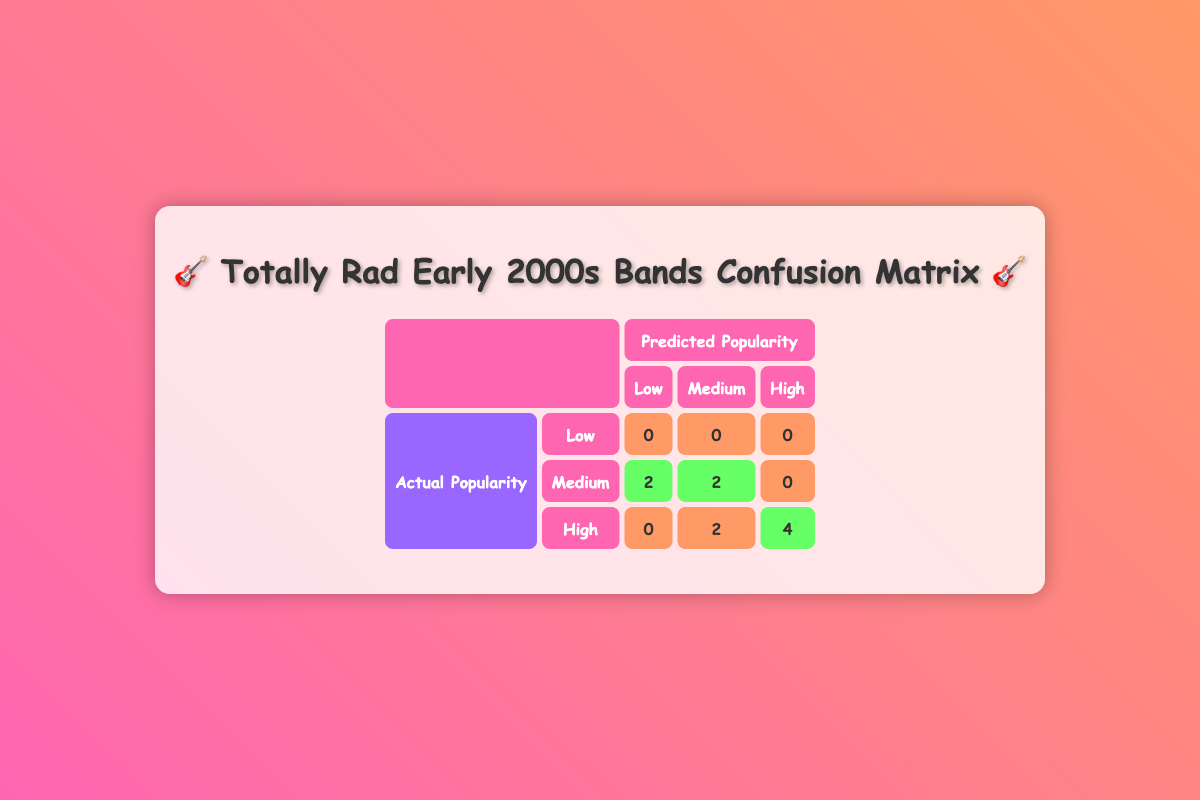What is the total number of artists classified as "Medium" in predicted popularity? In the table, we look at the row for "Medium" under "Predicted Popularity". There are two occurrences of "2" in that row, which indicate that there are two artists with "Medium" predicted popularity classified as "Medium" in actual popularity. Therefore, the total is 2 + 2 = 4.
Answer: 4 How many artists were correctly predicted as "High" based on social media engagement? We look at the row for "High" under "Actual Popularity". The last column for "High" shows "4", indicating that 4 artists were correctly predicted as high popularity.
Answer: 4 Is it true that no artists were predicted as "Low" popularity? Checking the table for the "Low" category, we see there are zero entries under "Low" in predicted popularity for both actual and predicted popularity rows. This confirms that the statement is true.
Answer: Yes What is the difference in the number of artists classified as "Low" and "High" for actual popularity? From the table, "Low" has 0 artists, while "High" has 4 artists. The difference is calculated as 4 (High) - 0 (Low) = 4.
Answer: 4 What percentage of artists were misclassified in terms of predicted popularity? First, we can determine the total number of artists, which is 10. Next, we can find the total misclassifications: there are 2 for "Medium" and 2 for "High", totaling 4 misclassified artists. The percentage is calculated as (4/10) * 100 = 40%.
Answer: 40% 